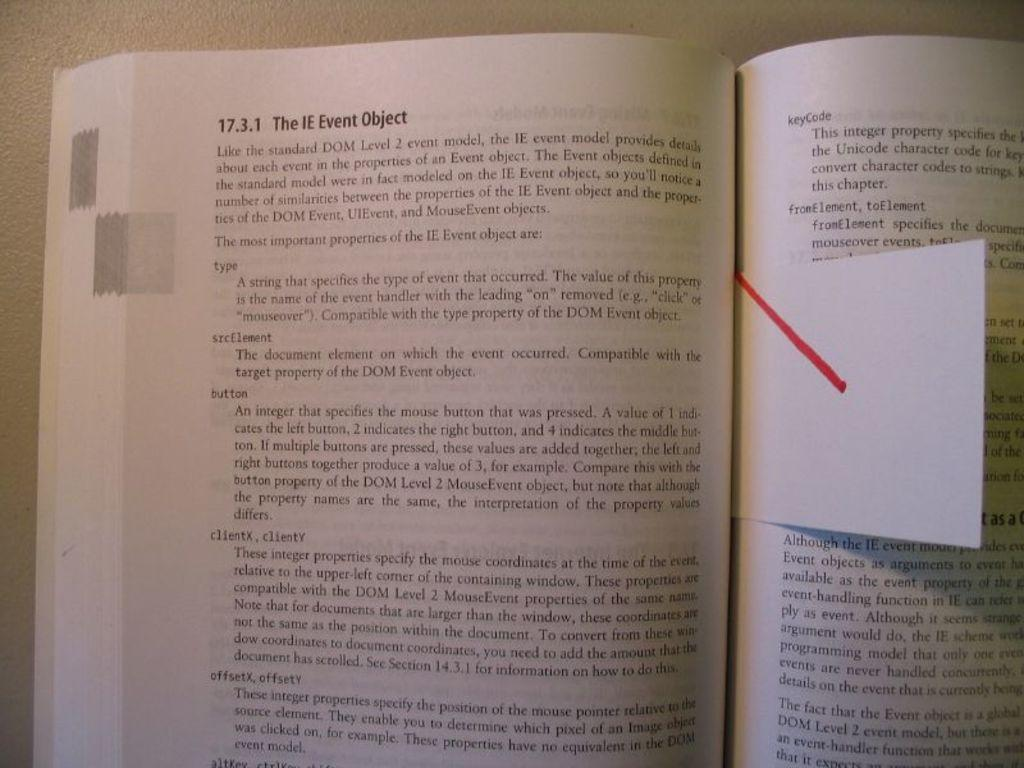<image>
Provide a brief description of the given image. Section 17.3.1 of this book is about The IE Event Object. 